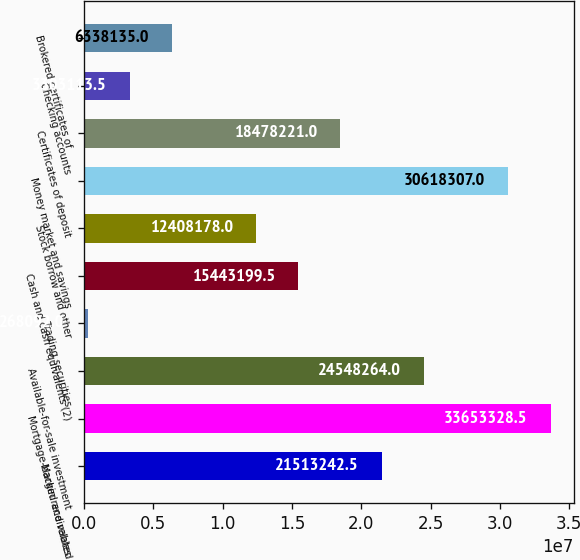Convert chart to OTSL. <chart><loc_0><loc_0><loc_500><loc_500><bar_chart><fcel>Margin receivables<fcel>Mortgage-backed and related<fcel>Available-for-sale investment<fcel>Trading securities<fcel>Cash and cash equivalents (2)<fcel>Stock borrow and other<fcel>Money market and savings<fcel>Certificates of deposit<fcel>Checking accounts<fcel>Brokered certificates of<nl><fcel>2.15132e+07<fcel>3.36533e+07<fcel>2.45483e+07<fcel>268092<fcel>1.54432e+07<fcel>1.24082e+07<fcel>3.06183e+07<fcel>1.84782e+07<fcel>3.30311e+06<fcel>6.33814e+06<nl></chart> 